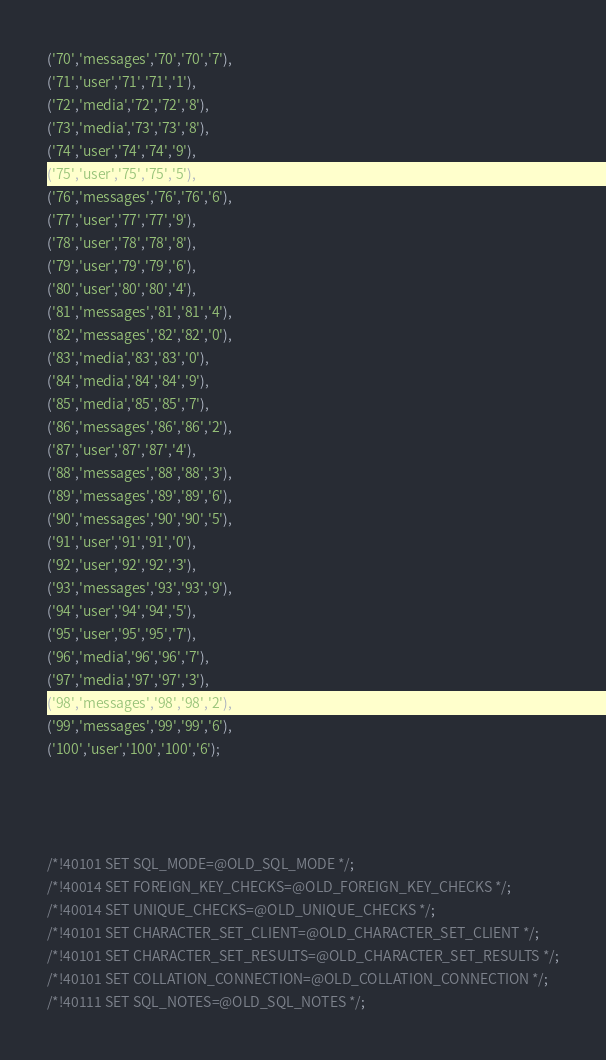<code> <loc_0><loc_0><loc_500><loc_500><_SQL_>('70','messages','70','70','7'),
('71','user','71','71','1'),
('72','media','72','72','8'),
('73','media','73','73','8'),
('74','user','74','74','9'),
('75','user','75','75','5'),
('76','messages','76','76','6'),
('77','user','77','77','9'),
('78','user','78','78','8'),
('79','user','79','79','6'),
('80','user','80','80','4'),
('81','messages','81','81','4'),
('82','messages','82','82','0'),
('83','media','83','83','0'),
('84','media','84','84','9'),
('85','media','85','85','7'),
('86','messages','86','86','2'),
('87','user','87','87','4'),
('88','messages','88','88','3'),
('89','messages','89','89','6'),
('90','messages','90','90','5'),
('91','user','91','91','0'),
('92','user','92','92','3'),
('93','messages','93','93','9'),
('94','user','94','94','5'),
('95','user','95','95','7'),
('96','media','96','96','7'),
('97','media','97','97','3'),
('98','messages','98','98','2'),
('99','messages','99','99','6'),
('100','user','100','100','6'); 




/*!40101 SET SQL_MODE=@OLD_SQL_MODE */;
/*!40014 SET FOREIGN_KEY_CHECKS=@OLD_FOREIGN_KEY_CHECKS */;
/*!40014 SET UNIQUE_CHECKS=@OLD_UNIQUE_CHECKS */;
/*!40101 SET CHARACTER_SET_CLIENT=@OLD_CHARACTER_SET_CLIENT */;
/*!40101 SET CHARACTER_SET_RESULTS=@OLD_CHARACTER_SET_RESULTS */;
/*!40101 SET COLLATION_CONNECTION=@OLD_COLLATION_CONNECTION */;
/*!40111 SET SQL_NOTES=@OLD_SQL_NOTES */;

</code> 